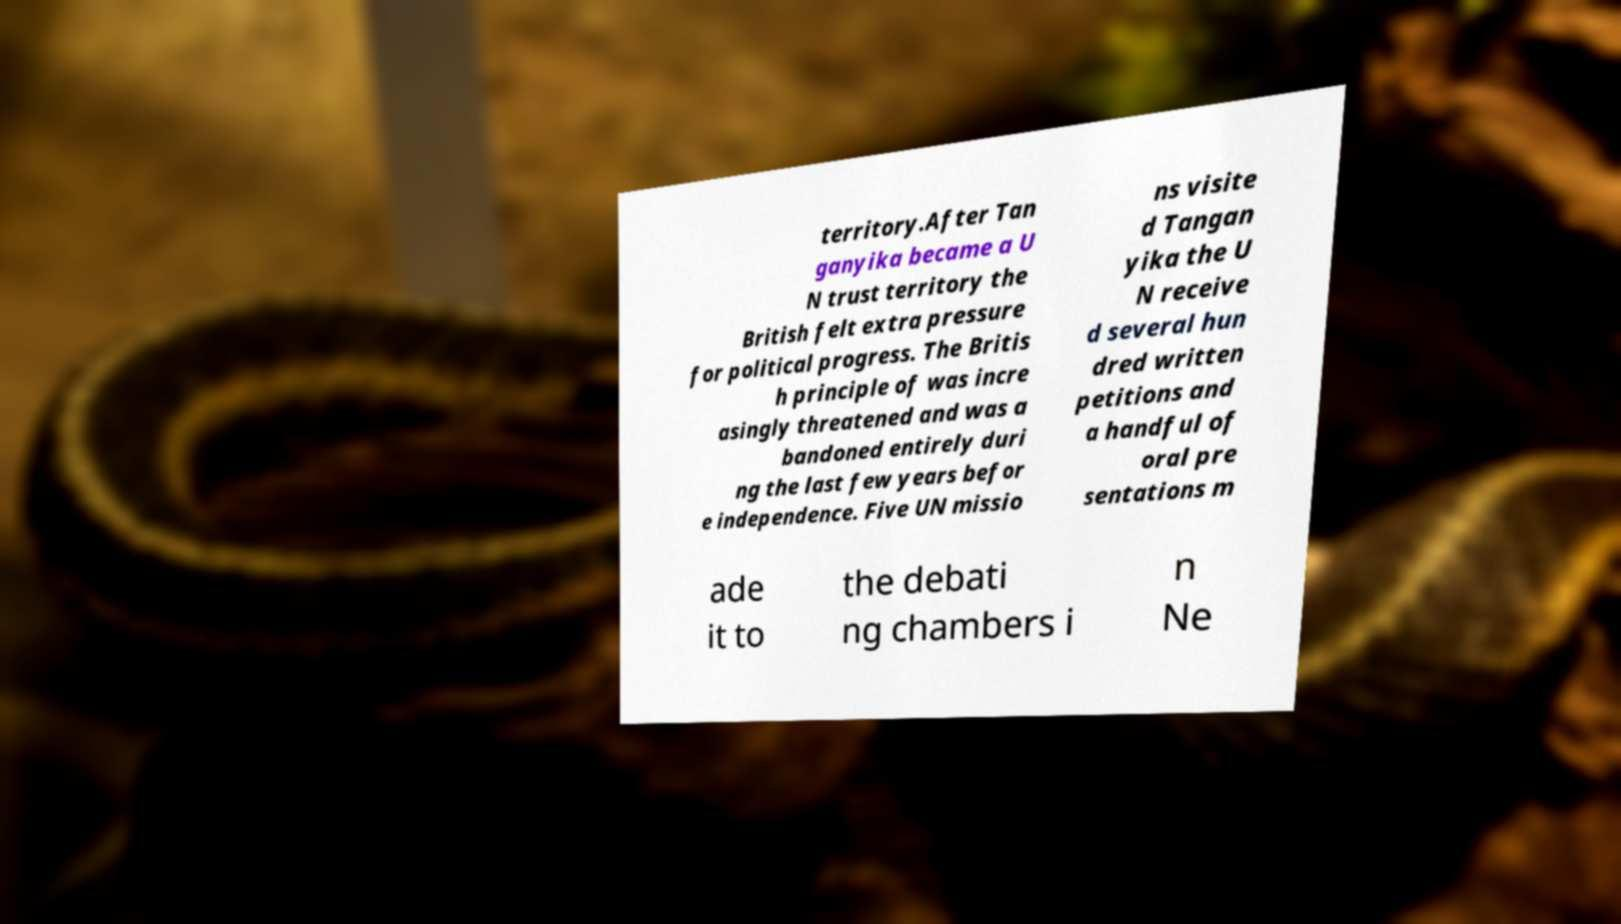Can you read and provide the text displayed in the image?This photo seems to have some interesting text. Can you extract and type it out for me? territory.After Tan ganyika became a U N trust territory the British felt extra pressure for political progress. The Britis h principle of was incre asingly threatened and was a bandoned entirely duri ng the last few years befor e independence. Five UN missio ns visite d Tangan yika the U N receive d several hun dred written petitions and a handful of oral pre sentations m ade it to the debati ng chambers i n Ne 